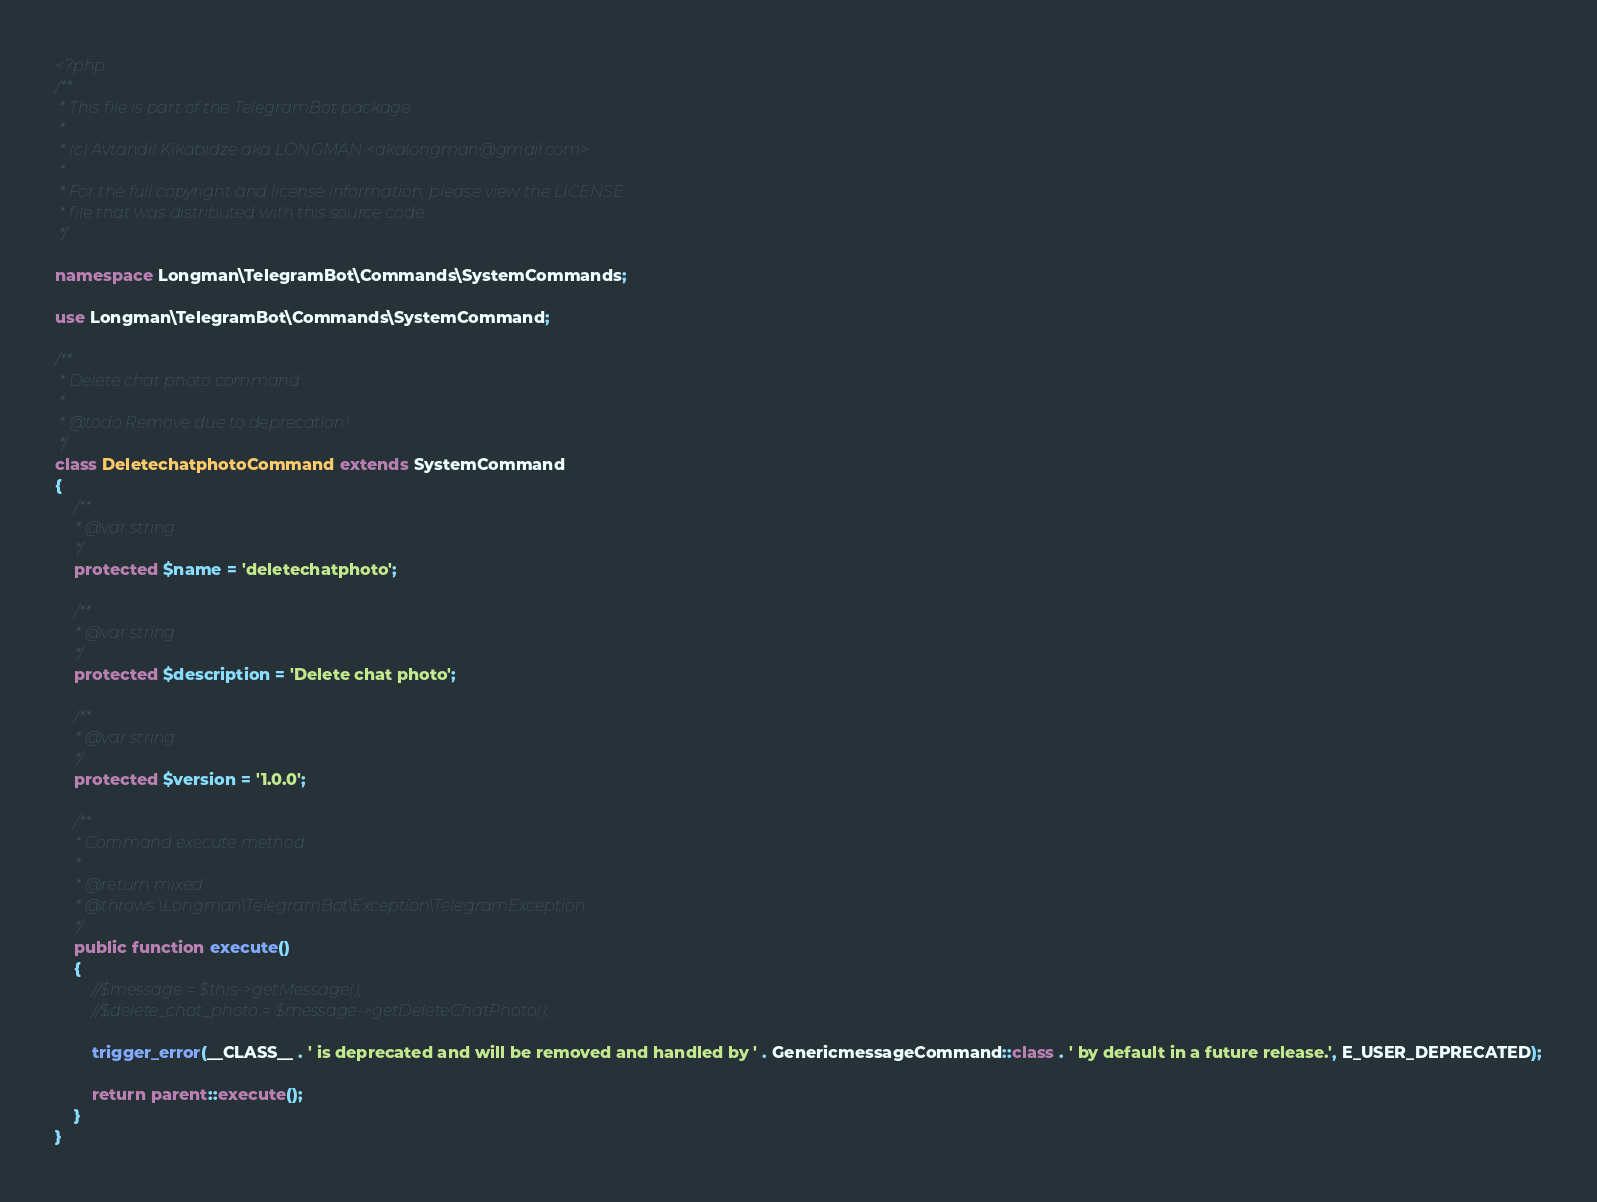Convert code to text. <code><loc_0><loc_0><loc_500><loc_500><_PHP_><?php
/**
 * This file is part of the TelegramBot package.
 *
 * (c) Avtandil Kikabidze aka LONGMAN <akalongman@gmail.com>
 *
 * For the full copyright and license information, please view the LICENSE
 * file that was distributed with this source code.
 */

namespace Longman\TelegramBot\Commands\SystemCommands;

use Longman\TelegramBot\Commands\SystemCommand;

/**
 * Delete chat photo command
 *
 * @todo Remove due to deprecation!
 */
class DeletechatphotoCommand extends SystemCommand
{
    /**
     * @var string
     */
    protected $name = 'deletechatphoto';

    /**
     * @var string
     */
    protected $description = 'Delete chat photo';

    /**
     * @var string
     */
    protected $version = '1.0.0';

    /**
     * Command execute method
     *
     * @return mixed
     * @throws \Longman\TelegramBot\Exception\TelegramException
     */
    public function execute()
    {
        //$message = $this->getMessage();
        //$delete_chat_photo = $message->getDeleteChatPhoto();

        trigger_error(__CLASS__ . ' is deprecated and will be removed and handled by ' . GenericmessageCommand::class . ' by default in a future release.', E_USER_DEPRECATED);

        return parent::execute();
    }
}
</code> 